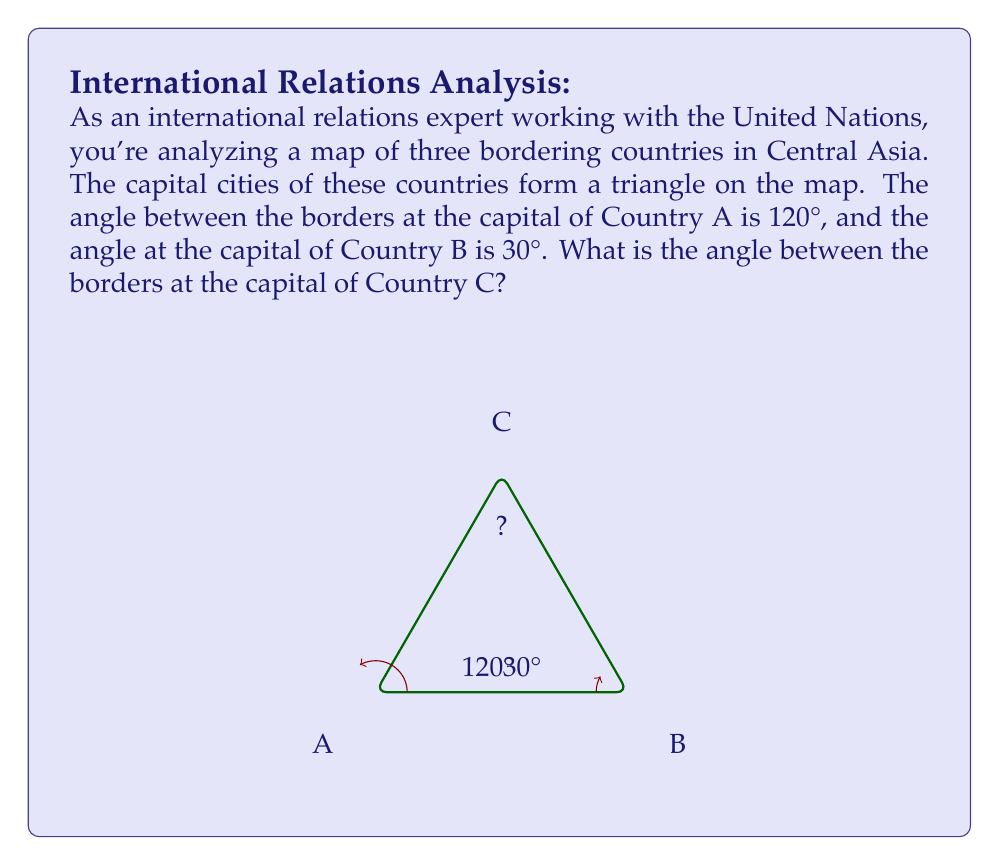Could you help me with this problem? To solve this problem, we'll use the fact that the sum of angles in a triangle is always 180°. Let's approach this step-by-step:

1) Let's denote the unknown angle at Country C as $x°$.

2) We know that in any triangle, the sum of all angles is 180°. We can express this as an equation:

   $$120° + 30° + x° = 180°$$

3) Simplify the left side of the equation:

   $$150° + x° = 180°$$

4) To solve for $x$, subtract 150° from both sides:

   $$x° = 180° - 150°$$

5) Simplify:

   $$x° = 30°$$

Therefore, the angle between the borders at the capital of Country C is 30°.

This problem illustrates how geometric principles can be applied to geographical and political contexts, which is relevant to international relations work. It also demonstrates how historical border formations (inspired by the persona's parent's teachings in history) can create interesting geometric patterns on maps.
Answer: The angle between the borders at the capital of Country C is 30°. 